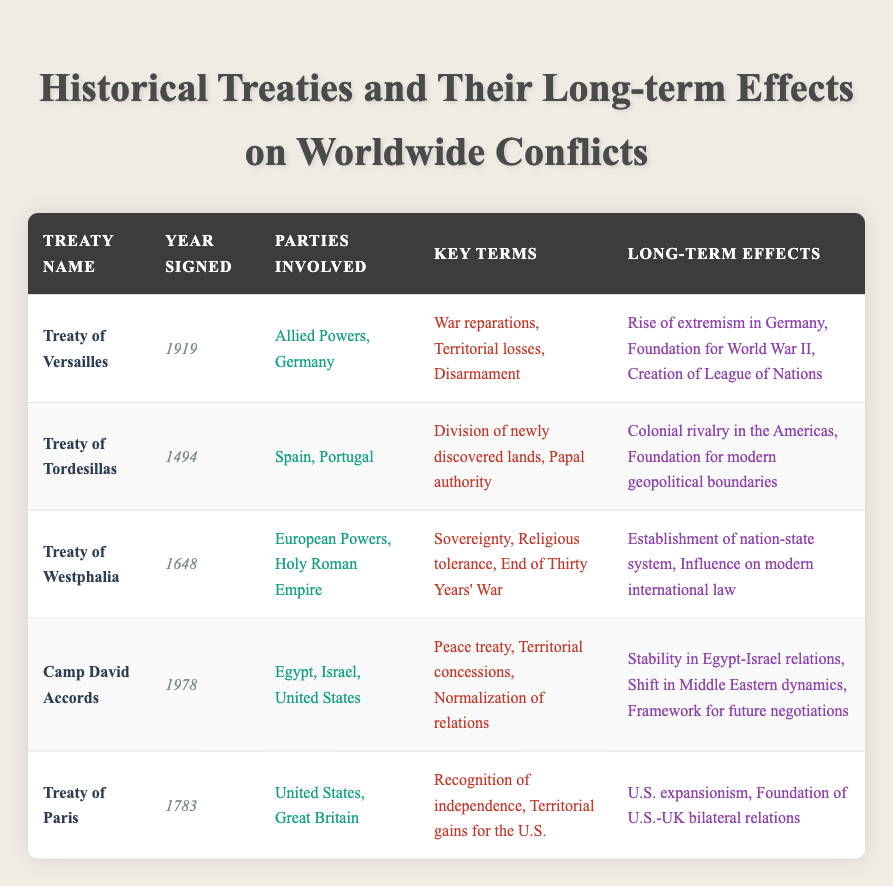What year was the Treaty of Versailles signed? The table lists the Treaty of Versailles along with its year signed in the corresponding columns. The Treaty of Versailles was signed in the year 1919.
Answer: 1919 What are the long-term effects of the Treaty of Tordesillas? The table indicates the long-term effects of the Treaty of Tordesillas in the fifth column. They are Colonial rivalry in the Americas and Foundation for modern geopolitical boundaries.
Answer: Colonial rivalry in the Americas, Foundation for modern geopolitical boundaries Did the Camp David Accords contribute to stability in the Middle East? The fifth column of the table explains the long-term effects of the Camp David Accords. One of the effects mentioned is Stability in Egypt-Israel relations, which indicates a positive contribution to stability in the region.
Answer: Yes How many parties were involved in both the Treaty of Paris and the Treaty of Versailles? The table shows the parties involved in both treaties. The Treaty of Paris involved 2 parties (United States, Great Britain) and the Treaty of Versailles also involved 2 parties (Allied Powers, Germany). Therefore, they have a combined total of 4 parties involved.
Answer: 4 Which treaty mentioned establishes a nation-state system? In the table, the Treaty of Westphalia is listed under the long-term effects column as establishing the nation-state system, which signifies its importance in political history.
Answer: Treaty of Westphalia 